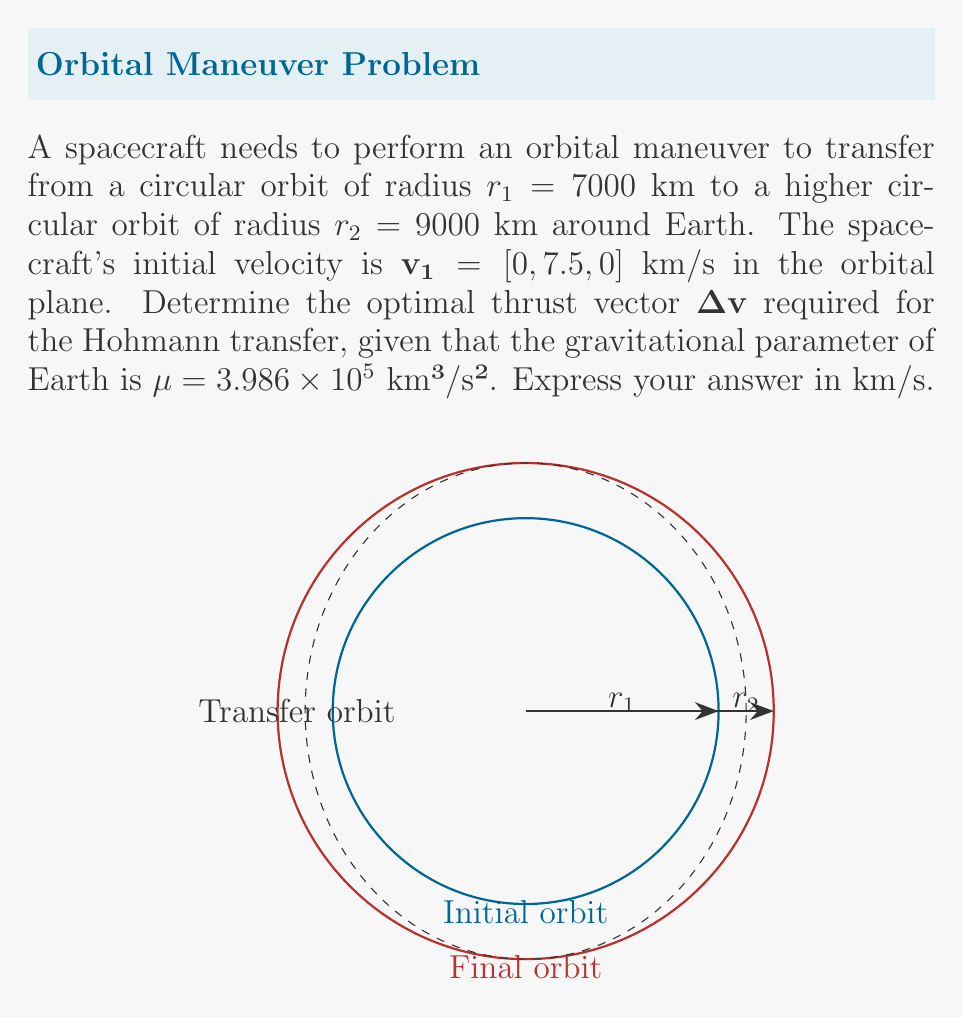Show me your answer to this math problem. Let's solve this problem step by step:

1) The Hohmann transfer is the most efficient way to change circular orbits. It consists of two impulses: one to enter the transfer orbit, and one to circularize at the final orbit.

2) First, we need to calculate the semi-major axis of the transfer orbit:
   $$a = \frac{r_1 + r_2}{2} = \frac{7000 + 9000}{2} = 8000 \text{ km}$$

3) The velocity at the periapsis of the transfer orbit (which is the same as the initial orbit radius) is:
   $$v_{p} = \sqrt{\mu(\frac{2}{r_1} - \frac{1}{a})} = \sqrt{3.986 \times 10^5(\frac{2}{7000} - \frac{1}{8000})} = 7.726 \text{ km/s}$$

4) The initial velocity magnitude is:
   $$|\mathbf{v_1}| = 7.5 \text{ km/s}$$

5) The first impulse $\Delta v_1$ is the difference between these velocities:
   $$\Delta v_1 = 7.726 - 7.5 = 0.226 \text{ km/s}$$

6) This impulse is applied in the direction of the initial velocity, so the first part of our $\Delta v$ vector is:
   $$\Delta \mathbf{v_1} = [0, 0.226, 0] \text{ km/s}$$

7) Now, let's calculate the velocity at the apoapsis of the transfer orbit:
   $$v_{a} = \sqrt{\mu(\frac{2}{r_2} - \frac{1}{a})} = \sqrt{3.986 \times 10^5(\frac{2}{9000} - \frac{1}{8000})} = 6.565 \text{ km/s}$$

8) The final circular orbit velocity at $r_2$ is:
   $$v_2 = \sqrt{\frac{\mu}{r_2}} = \sqrt{\frac{3.986 \times 10^5}{9000}} = 6.644 \text{ km/s}$$

9) The second impulse $\Delta v_2$ is the difference between these velocities:
   $$\Delta v_2 = 6.644 - 6.565 = 0.079 \text{ km/s}$$

10) This impulse is also applied in the direction of motion, so the second part of our $\Delta v$ vector is:
    $$\Delta \mathbf{v_2} = [0, 0.079, 0] \text{ km/s}$$

11) The total $\Delta v$ vector is the sum of these two impulses:
    $$\mathbf{\Delta v} = \Delta \mathbf{v_1} + \Delta \mathbf{v_2} = [0, 0.226, 0] + [0, 0.079, 0] = [0, 0.305, 0] \text{ km/s}$$

Therefore, the optimal thrust vector for the Hohmann transfer is $[0, 0.305, 0]$ km/s.
Answer: $[0, 0.305, 0]$ km/s 